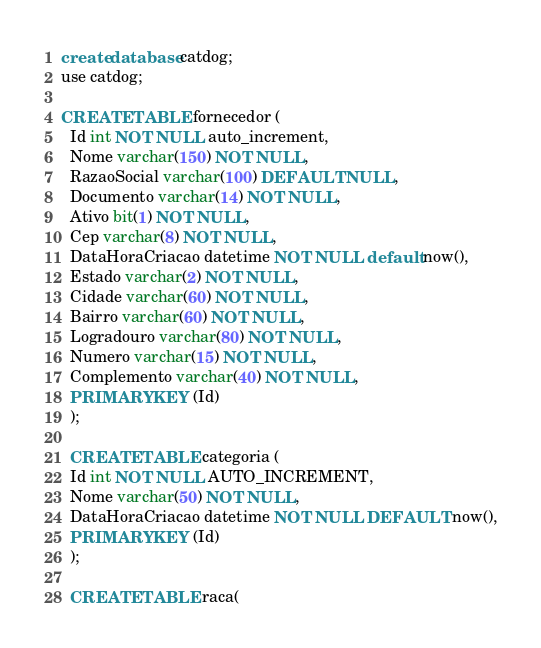Convert code to text. <code><loc_0><loc_0><loc_500><loc_500><_SQL_>create database catdog;
use catdog;

CREATE TABLE fornecedor (
  Id int NOT NULL auto_increment,
  Nome varchar(150) NOT NULL,
  RazaoSocial varchar(100) DEFAULT NULL,
  Documento varchar(14) NOT NULL,
  Ativo bit(1) NOT NULL,
  Cep varchar(8) NOT NULL,
  DataHoraCriacao datetime NOT NULL default now(),
  Estado varchar(2) NOT NULL,
  Cidade varchar(60) NOT NULL,
  Bairro varchar(60) NOT NULL,
  Logradouro varchar(80) NOT NULL,
  Numero varchar(15) NOT NULL,
  Complemento varchar(40) NOT NULL,
  PRIMARY KEY (Id)
  );

  CREATE TABLE categoria (
  Id int NOT NULL AUTO_INCREMENT,
  Nome varchar(50) NOT NULL,
  DataHoraCriacao datetime NOT NULL DEFAULT now(),
  PRIMARY KEY (Id)
  );
  
  CREATE TABLE raca(</code> 